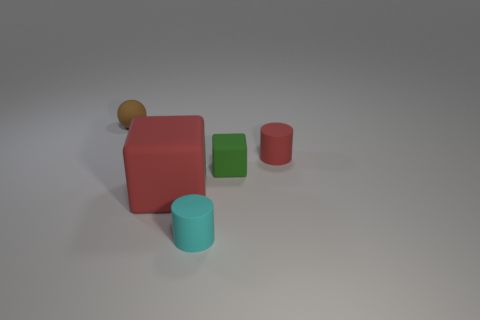Are there an equal number of rubber things on the right side of the big matte object and cylinders behind the green block?
Your response must be concise. No. There is a brown matte ball; is it the same size as the cylinder right of the tiny cyan cylinder?
Provide a succinct answer. Yes. Are there more brown objects that are in front of the small brown object than small brown balls?
Make the answer very short. No. What number of matte cubes have the same size as the brown ball?
Provide a short and direct response. 1. Does the object that is to the right of the green rubber cube have the same size as the cylinder that is in front of the big red object?
Keep it short and to the point. Yes. Are there more small cyan rubber things that are behind the tiny green rubber thing than tiny rubber blocks in front of the large matte object?
Your answer should be very brief. No. What number of large green rubber things have the same shape as the tiny cyan matte object?
Your answer should be very brief. 0. What is the material of the red object that is the same size as the rubber sphere?
Your answer should be compact. Rubber. Are there any tiny red objects made of the same material as the cyan object?
Provide a short and direct response. Yes. Is the number of small brown things in front of the red matte cylinder less than the number of cyan matte things?
Provide a short and direct response. Yes. 